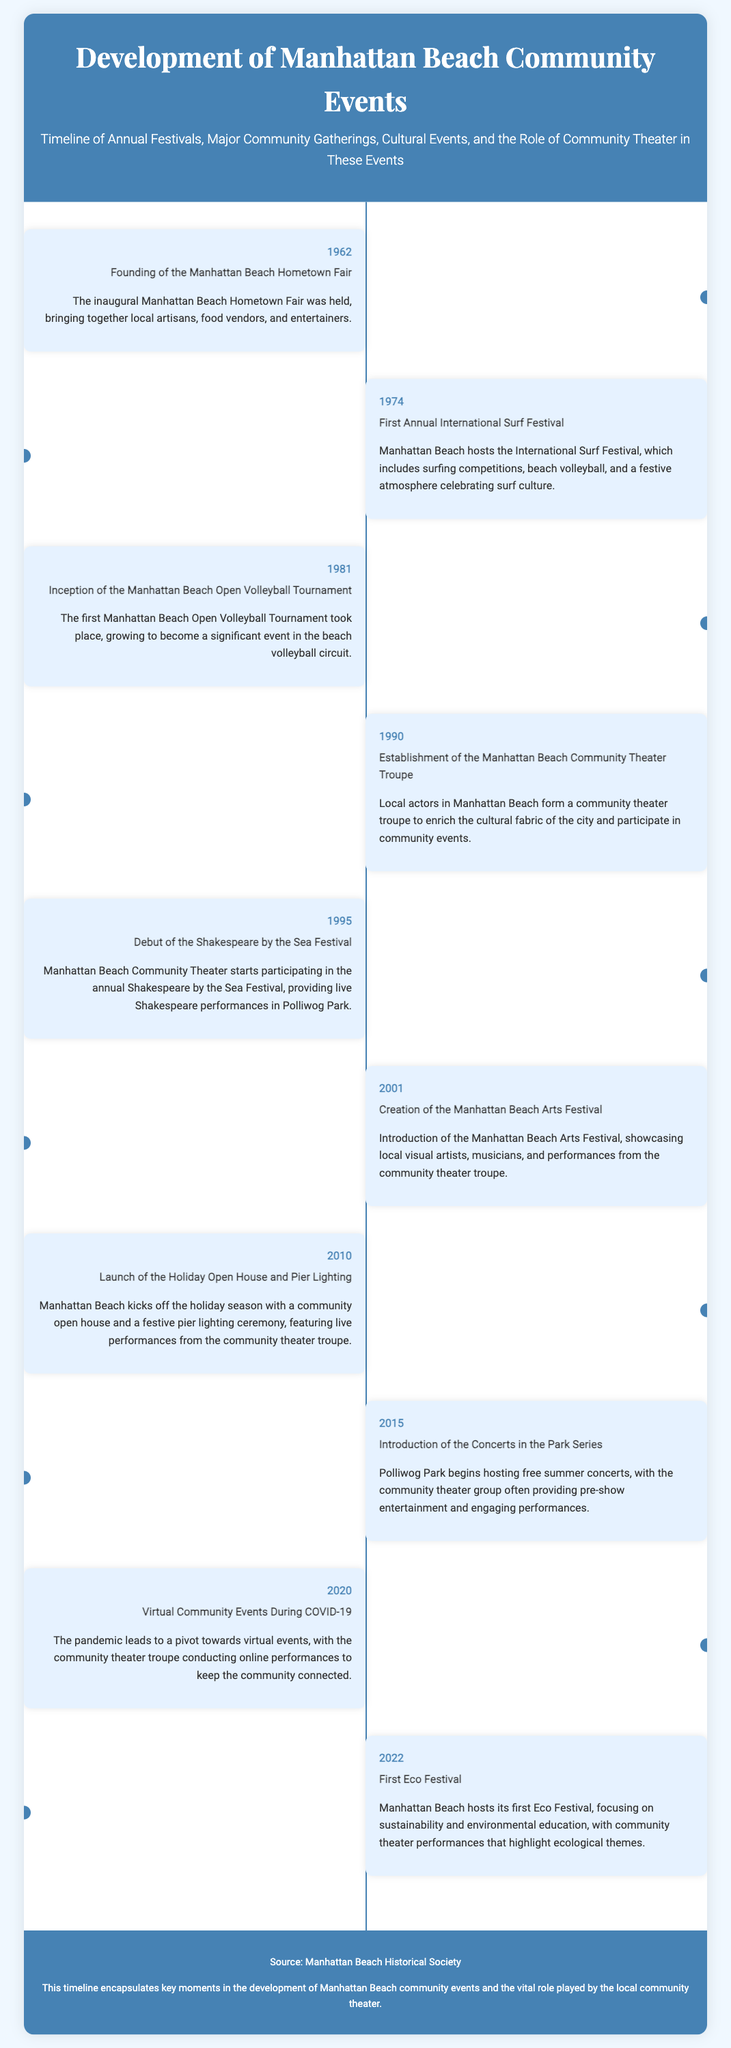What year was the Manhattan Beach Hometown Fair founded? The document states that the inaugural Manhattan Beach Hometown Fair was held in 1962.
Answer: 1962 What event began in 1990? The establishment of the Manhattan Beach Community Theater Troupe occurred in 1990 as per the timeline.
Answer: Manhattan Beach Community Theater Troupe Which festival debuted in 1995? The timeline mentions the debut of the Shakespeare by the Sea Festival in 1995.
Answer: Shakespeare by the Sea Festival How often are the Concerts in the Park held? The event was introduced in 2015 and is described as a series of free summer concerts.
Answer: Summer What role does the community theater troupe play at the Holiday Open House and Pier Lighting? According to the timeline, the community theater troupe provides live performances during the event.
Answer: Live performances In which year did Manhattan Beach host its first Eco Festival? The timeline indicates that the first Eco Festival was held in 2022.
Answer: 2022 What is a significant cultural contribution of the community theater in 2001? The community theater troupe's performances were showcased at the Manhattan Beach Arts Festival.
Answer: Performances at the Arts Festival What prompted virtual community events in 2020? The timeline explains that the pandemic led to a shift towards virtual events.
Answer: The pandemic 